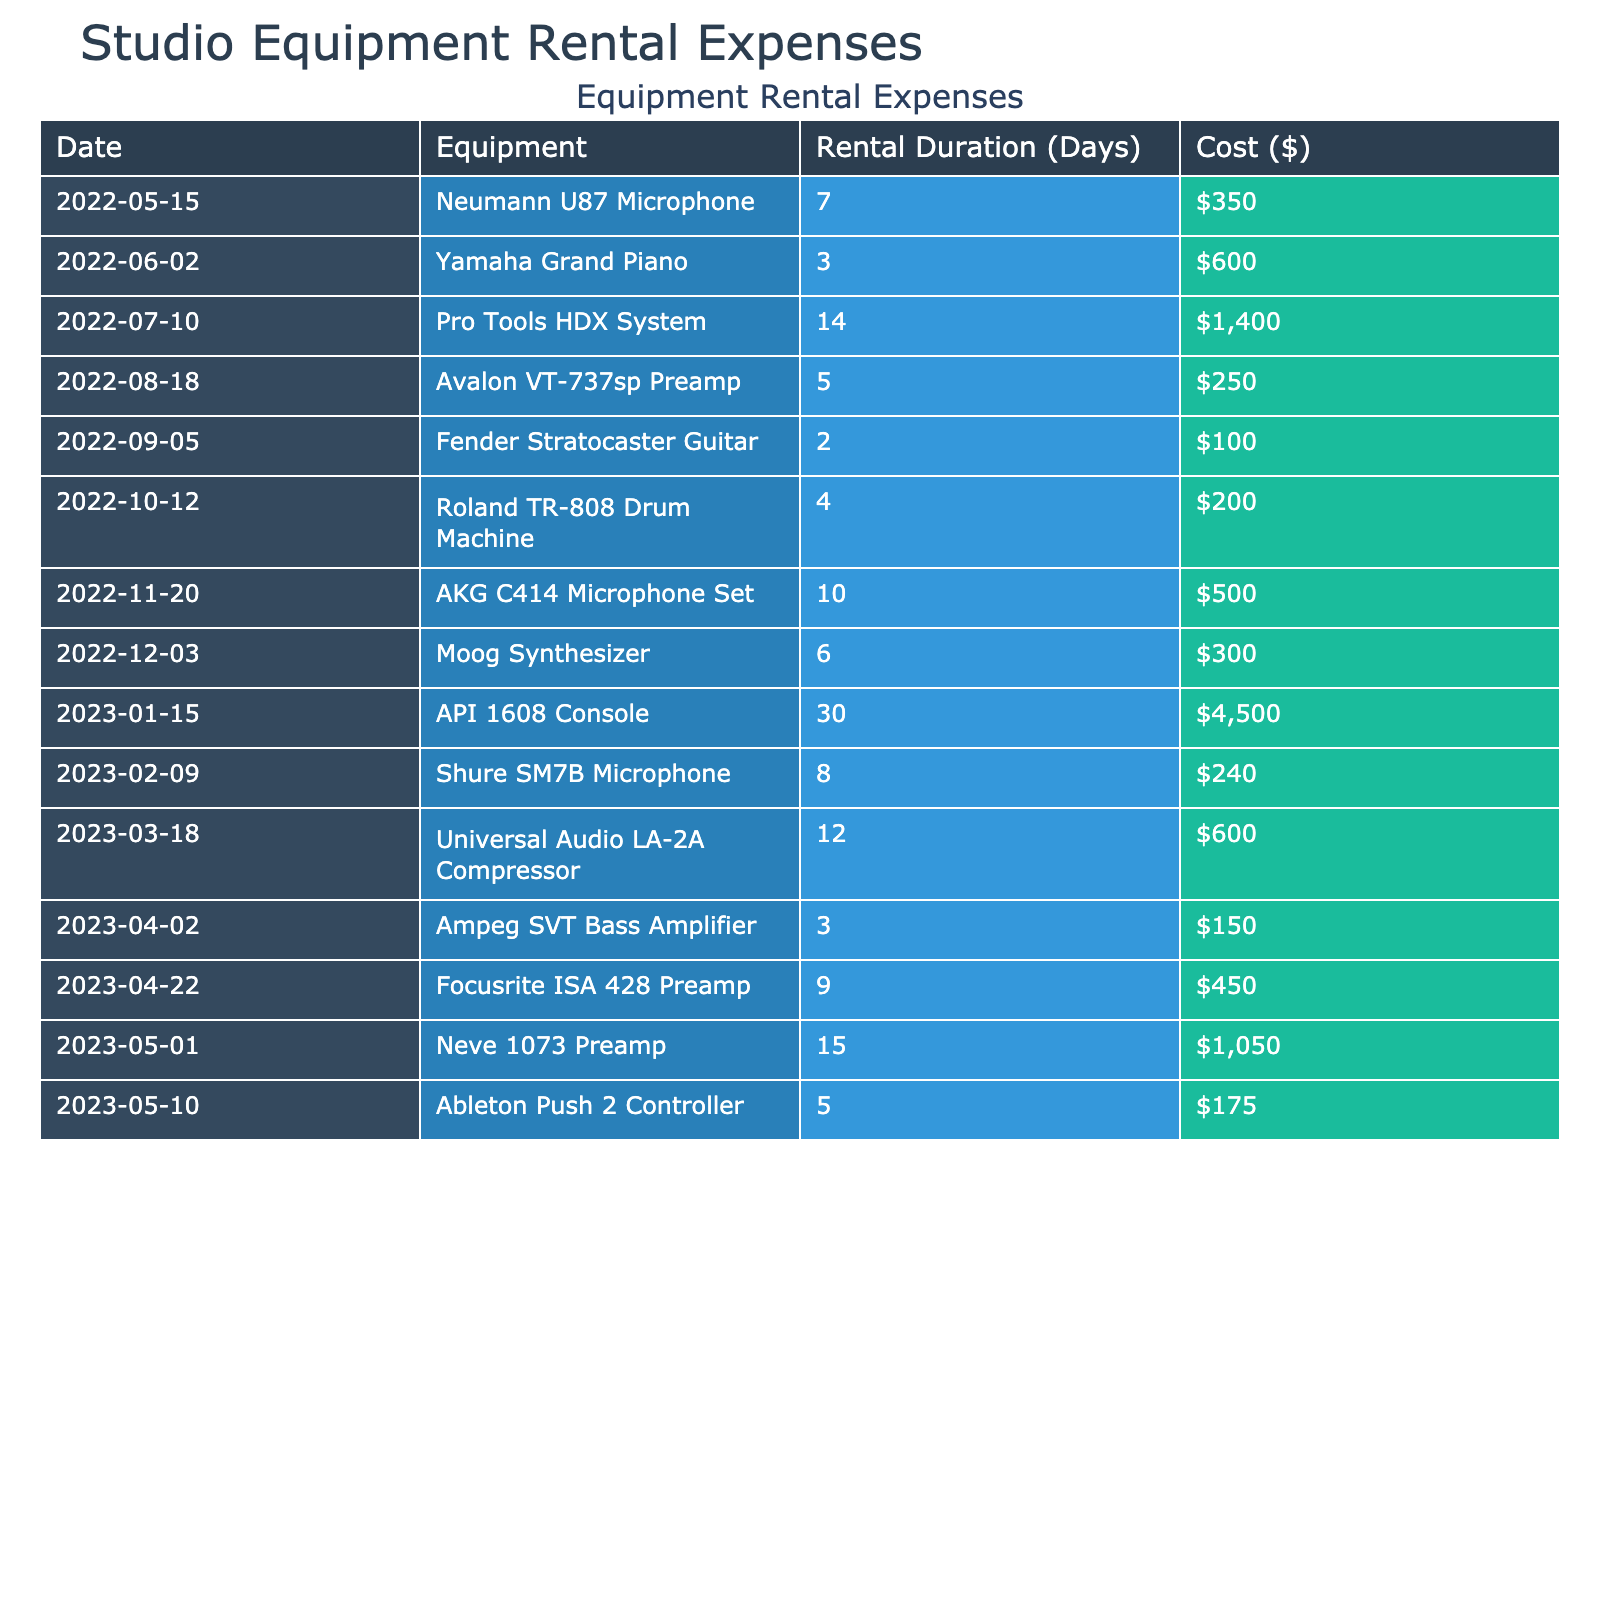What was the total cost of equipment rentals in January 2023? In January 2023, the only rental listed is the API 1608 Console, which costs $4,500. Since that is the only rental for that month, the total cost is $4,500.
Answer: $4,500 Which equipment had the longest rental duration? The API 1608 Console was rented for 30 days, which is the longest rental duration in the table.
Answer: API 1608 Console What is the average cost of equipment rented from March 2023 to May 2023? The rented equipment during that period is: Universal Audio LA-2A Compressor ($600), Ampeg SVT Bass Amplifier ($150), Focusrite ISA 428 Preamp ($450), Neve 1073 Preamp ($1,050), and Ableton Push 2 Controller ($175). The total cost is $2,425. There are 5 rentals, so the average cost is $2,425/5 = $485.
Answer: $485 Did any equipment rental exceed $1,000? Yes, the API 1608 Console cost $4,500, which exceeds $1,000.
Answer: Yes What was the total rental cost for all equipment in 2022? The total costs for 2022 are $350 (Neumann U87 Microphone) + $600 (Yamaha Grand Piano) + $1,400 (Pro Tools HDX System) + $250 (Avalon VT-737sp Preamp) + $100 (Fender Stratocaster Guitar) + $200 (Roland TR-808 Drum Machine) + $500 (AKG C414 Microphone Set) + $300 (Moog Synthesizer) = $3,800.
Answer: $3,800 Which month had the highest rental expense? In January 2023, the rental expense is $4,500 for the API 1608 Console, which is the highest compared to other months.
Answer: January 2023 How many different types of equipment were rented in total? There are 14 different types of equipment listed in the table, from the Neumann U87 Microphone to the Ableton Push 2 Controller.
Answer: 14 What was the cost difference between the most expensive and least expensive equipment rented? The most expensive rental is the API 1608 Console at $4,500, and the least expensive is the Fender Stratocaster Guitar at $100. The cost difference is $4,500 - $100 = $4,400.
Answer: $4,400 Is there any equipment that was rented for more than 10 days? Yes, the API 1608 Console was rented for 30 days, exceeding 10 days.
Answer: Yes What is the total rental duration for all equipment in the year? Summing the rental durations yields: 7 + 3 + 14 + 5 + 2 + 4 + 10 + 6 + 30 + 8 + 12 + 3 + 9 + 15 + 5 = 2, 20 days.
Answer: 20 days What percentage of the total expenses in the table is attributed to the API 1608 Console? The total expenses are $3,800 (from 2022) + $2,425 (from March to May 2023) + $4,500 (from January 2023) = $10,725. The API 1608 Console costs $4,500, so the percentage is ($4,500/$10,725) * 100 ≈ 41.92%.
Answer: 41.92% 